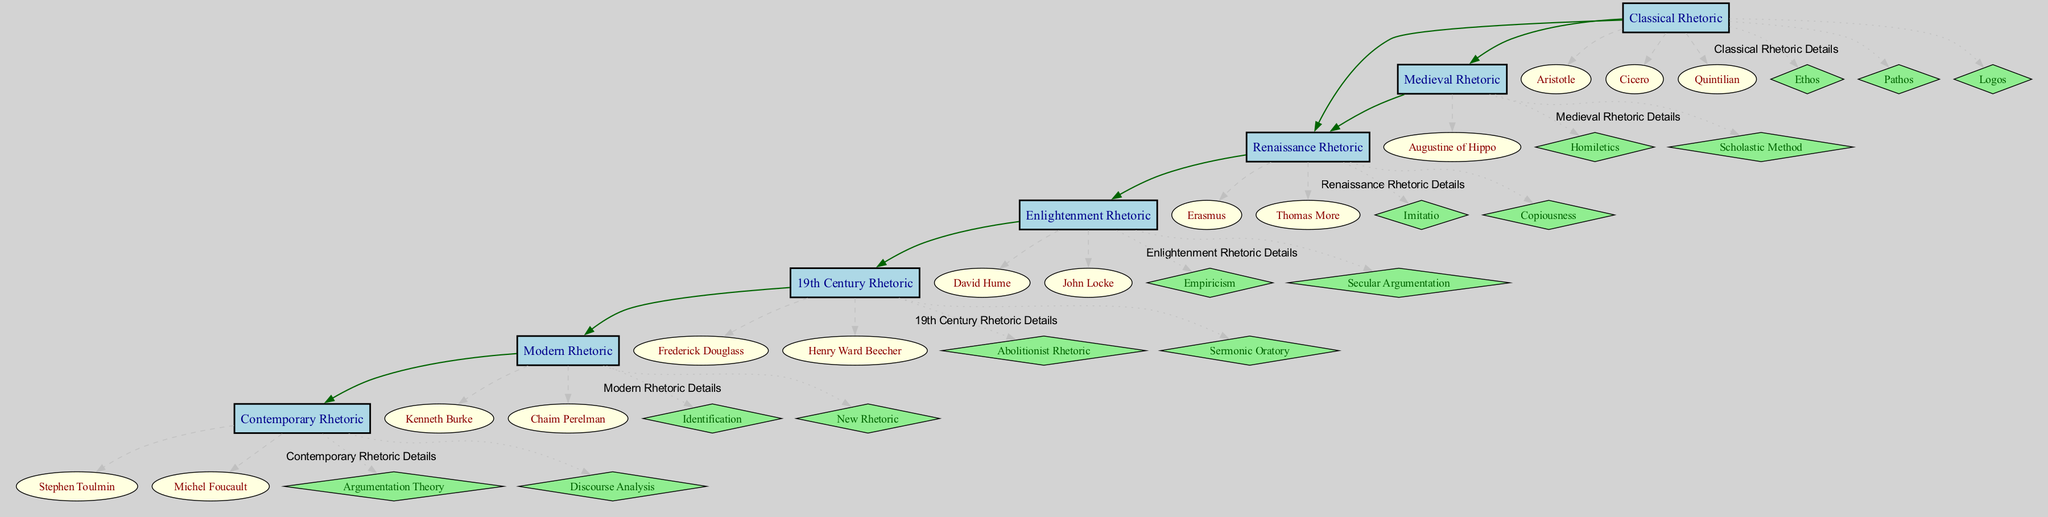What is the first branch in the family tree? The first branch is "Medieval Rhetoric," which emerges from the roots of "Classical Rhetoric." It is visually positioned directly below the roots in the diagram.
Answer: Medieval Rhetoric How many techniques are associated with Classical Rhetoric? The diagram shows that "Classical Rhetoric" has three associated techniques listed under it: Ethos, Pathos, and Logos. Counting these gives a total of three techniques.
Answer: 3 Who are the figures in Renaissance Rhetoric? To find the figures in "Renaissance Rhetoric," we look directly at the details in the subgraph of that era, which lists Erasmus and Thomas More. Thus, the answer includes these two figures.
Answer: Erasmus, Thomas More Which technique is unique to Contemporary Rhetoric? To answer this, we look specifically at the techniques listed under "Contemporary Rhetoric," and notice that "Discourse Analysis" is only associated with this era, making it unique.
Answer: Discourse Analysis What is the relationship between Enlightenment Rhetoric and 19th Century Rhetoric? "19th Century Rhetoric" is shown to have "Enlightenment Rhetoric" as its influence. This is represented by an edge connecting the two in the diagram. Thus, the answer describes this direct influence relationship.
Answer: Influence How many figures are listed under 19th Century Rhetoric? The diagram indicates that there are two figures associated with "19th Century Rhetoric," specifically Frederick Douglass and Henry Ward Beecher, which can be counted directly in the subgraph for that era.
Answer: 2 What techniques were developed during the Enlightenment Rhetoric? Based on the techniques shown directly under "Enlightenment Rhetoric," we can identify two techniques: Empiricism and Secular Argumentation. Hence, the answer lists these methods.
Answer: Empiricism, Secular Argumentation What do the edges in the diagram represent? The edges between the nodes signify the influences of one rhetorical era on another. They help visualize the flow of influence and evolution of techniques over time within the family tree structure.
Answer: Influences Which era follows Renaissance Rhetoric in the family tree? By examining the diagram, we determine that "Enlightenment Rhetoric" immediately follows "Renaissance Rhetoric," making this the next sequential era in the tree structure.
Answer: Enlightenment Rhetoric 